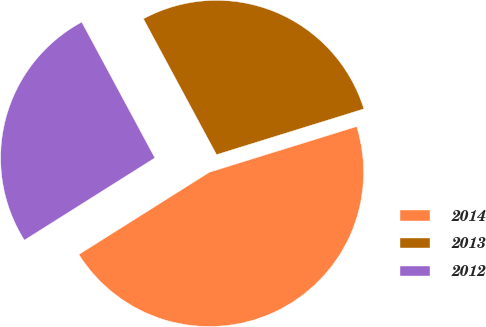Convert chart. <chart><loc_0><loc_0><loc_500><loc_500><pie_chart><fcel>2014<fcel>2013<fcel>2012<nl><fcel>45.84%<fcel>28.07%<fcel>26.09%<nl></chart> 